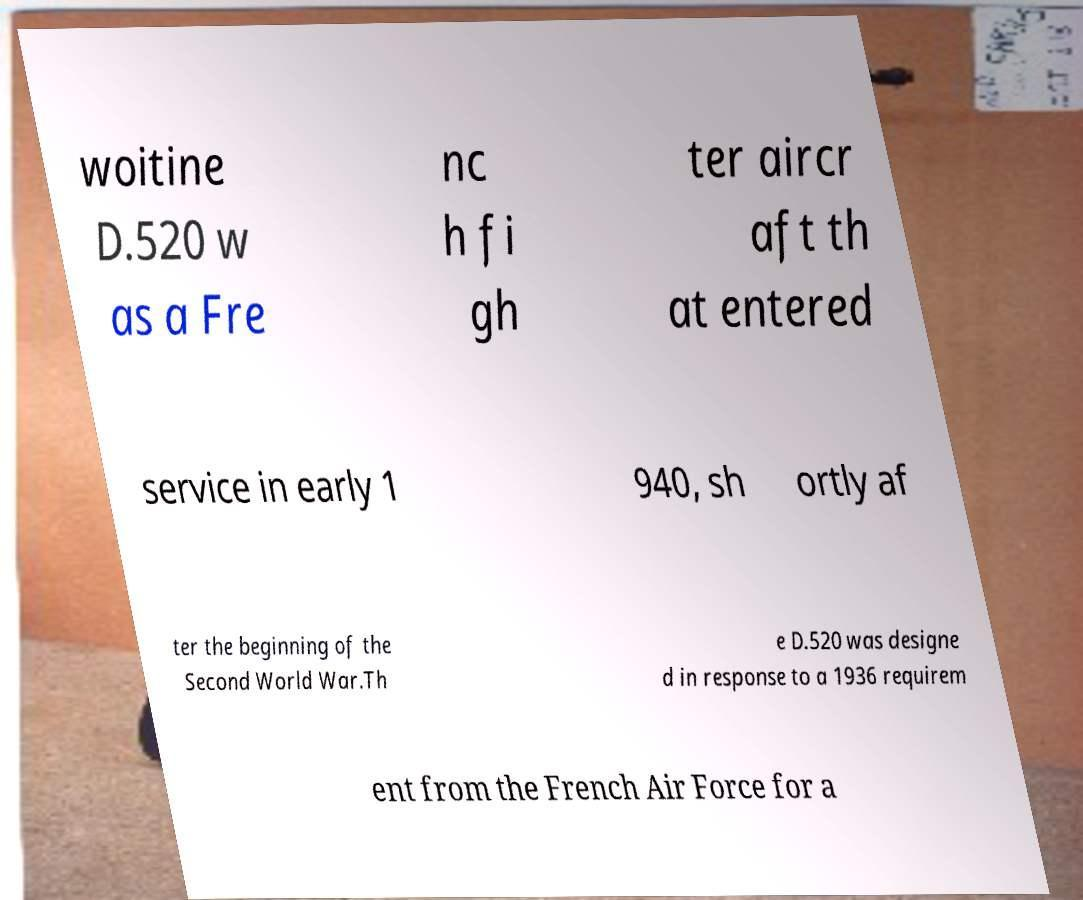Could you extract and type out the text from this image? woitine D.520 w as a Fre nc h fi gh ter aircr aft th at entered service in early 1 940, sh ortly af ter the beginning of the Second World War.Th e D.520 was designe d in response to a 1936 requirem ent from the French Air Force for a 